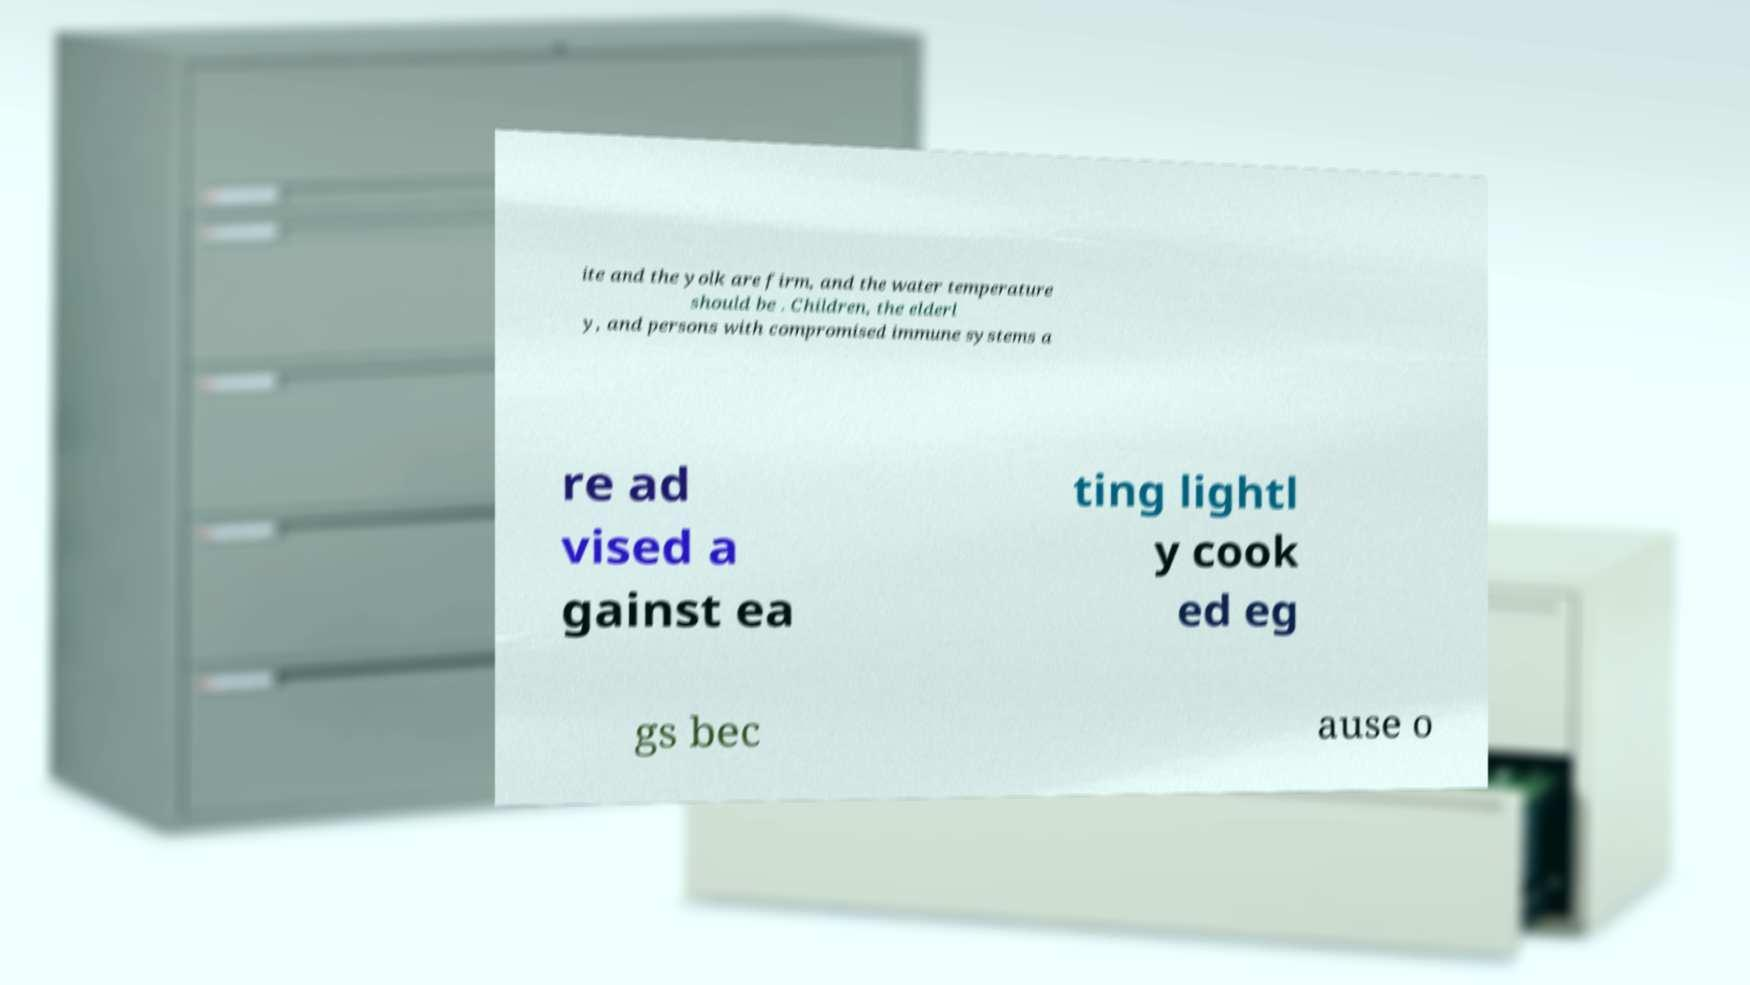Please read and relay the text visible in this image. What does it say? ite and the yolk are firm, and the water temperature should be . Children, the elderl y, and persons with compromised immune systems a re ad vised a gainst ea ting lightl y cook ed eg gs bec ause o 